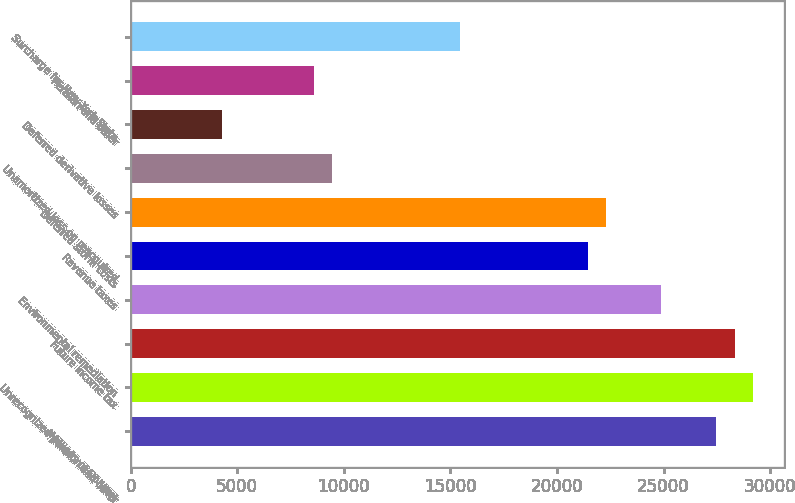<chart> <loc_0><loc_0><loc_500><loc_500><bar_chart><fcel>(Millions of Dollars)<fcel>Unrecognized pension and other<fcel>Future income tax<fcel>Environmental remediation<fcel>Revenue taxes<fcel>Deferred storm costs<fcel>Unamortized loss on reacquired<fcel>Deferred derivative losses<fcel>Pension and other<fcel>Surcharge for New York State<nl><fcel>27476<fcel>29193<fcel>28334.5<fcel>24900.5<fcel>21466.5<fcel>22325<fcel>9447.5<fcel>4296.5<fcel>8589<fcel>15457<nl></chart> 